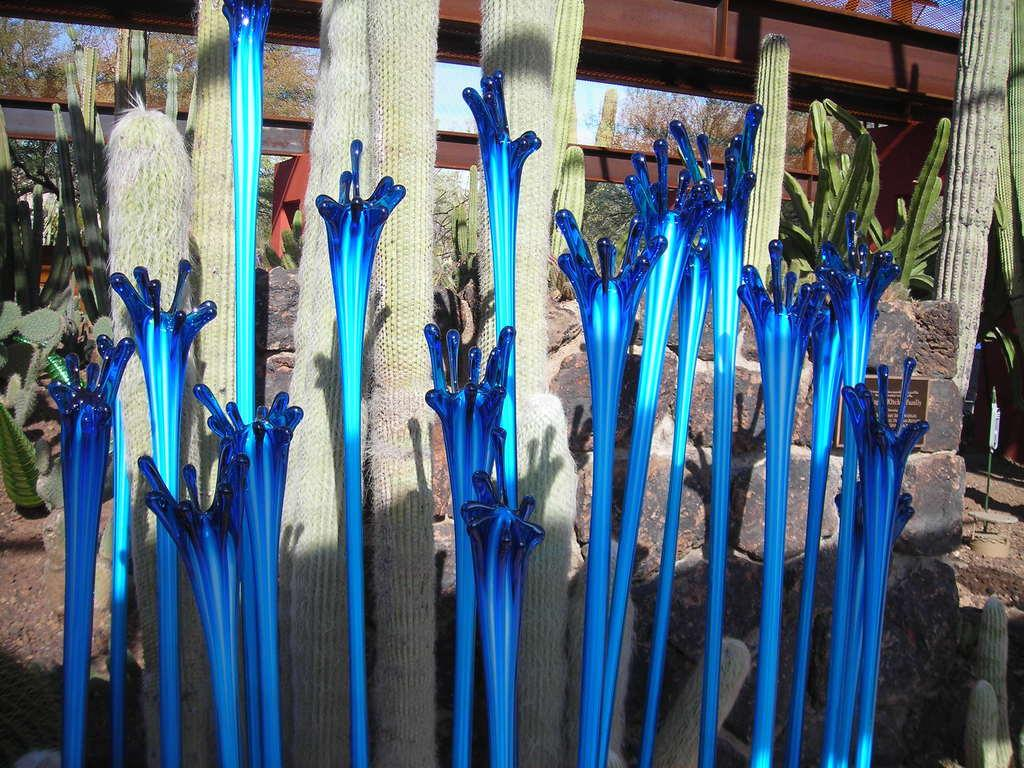What type of plants are in the middle of the image? There are cactus plants in the middle of the image. What can be seen at the top of the image? There are iron rods at the top of the image. What type of flowers are present in the middle of the image? There are blue color plastic flowers in the middle of the image. What type of structure is visible in the background of the image? There is a stone wall in the background of the image. How many toothbrushes are visible in the image? There are no toothbrushes present in the image. What memory is being evoked by the image? The image does not evoke a specific memory; it is a still image of cactus plants, iron rods, plastic flowers, and a stone wall. 